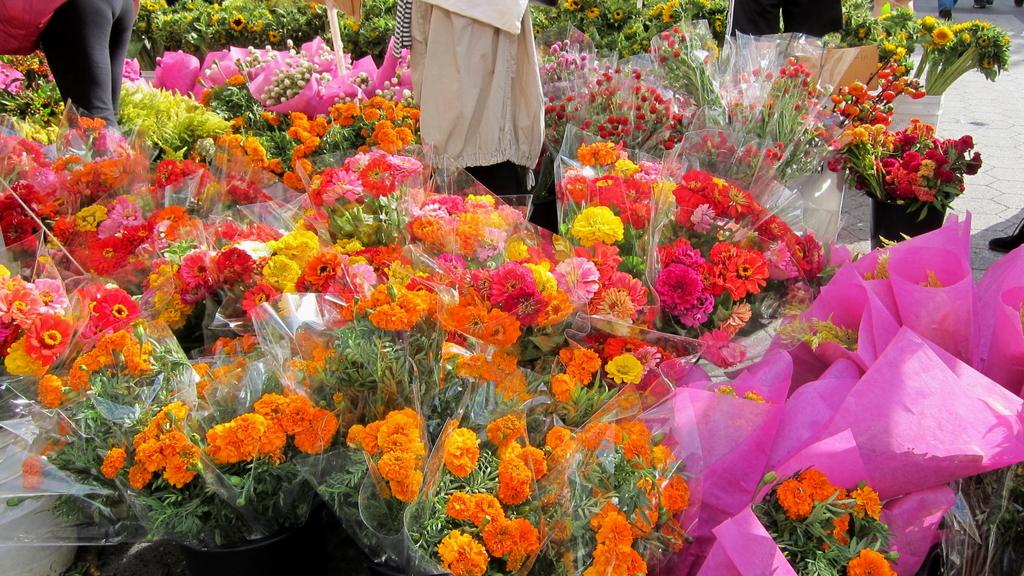What type of living organisms can be seen in the image? Flowers are visible in the image. What is the opinion of the flowers about the recent changes in the weather? The image does not provide any information about the flowers' opinions, as flowers do not have the ability to express opinions. 